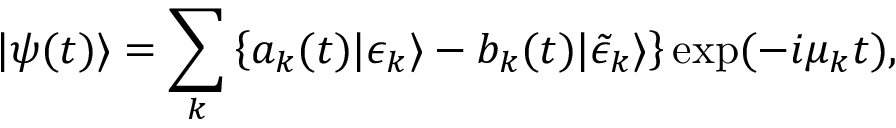Convert formula to latex. <formula><loc_0><loc_0><loc_500><loc_500>| \psi ( t ) \rangle = \sum _ { k } \left \{ a _ { k } ( t ) | \epsilon _ { k } \rangle - b _ { k } ( t ) | \tilde { \epsilon } _ { k } \rangle \right \} \exp ( - i \mu _ { k } t ) ,</formula> 